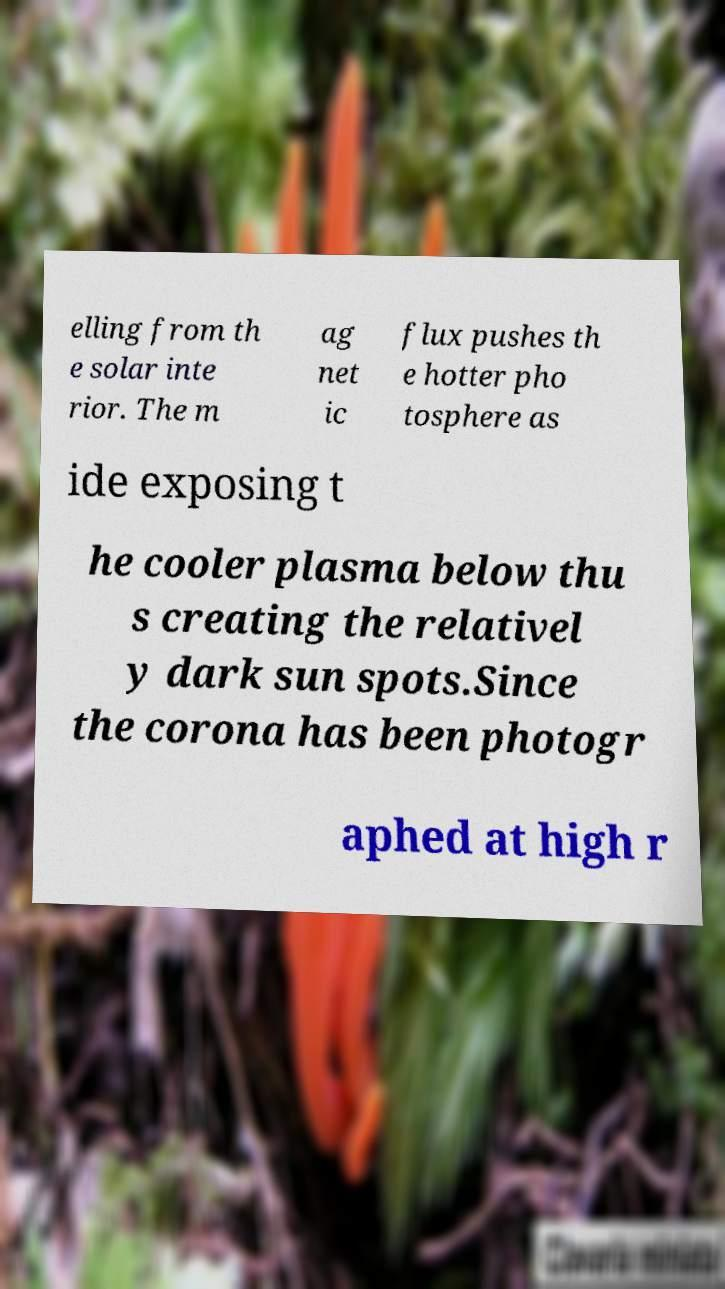Can you read and provide the text displayed in the image?This photo seems to have some interesting text. Can you extract and type it out for me? elling from th e solar inte rior. The m ag net ic flux pushes th e hotter pho tosphere as ide exposing t he cooler plasma below thu s creating the relativel y dark sun spots.Since the corona has been photogr aphed at high r 